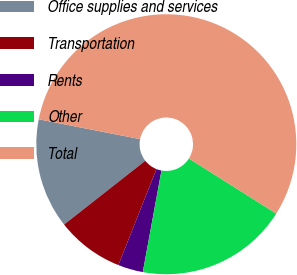Convert chart. <chart><loc_0><loc_0><loc_500><loc_500><pie_chart><fcel>Office supplies and services<fcel>Transportation<fcel>Rents<fcel>Other<fcel>Total<nl><fcel>13.67%<fcel>8.39%<fcel>3.12%<fcel>18.94%<fcel>55.88%<nl></chart> 